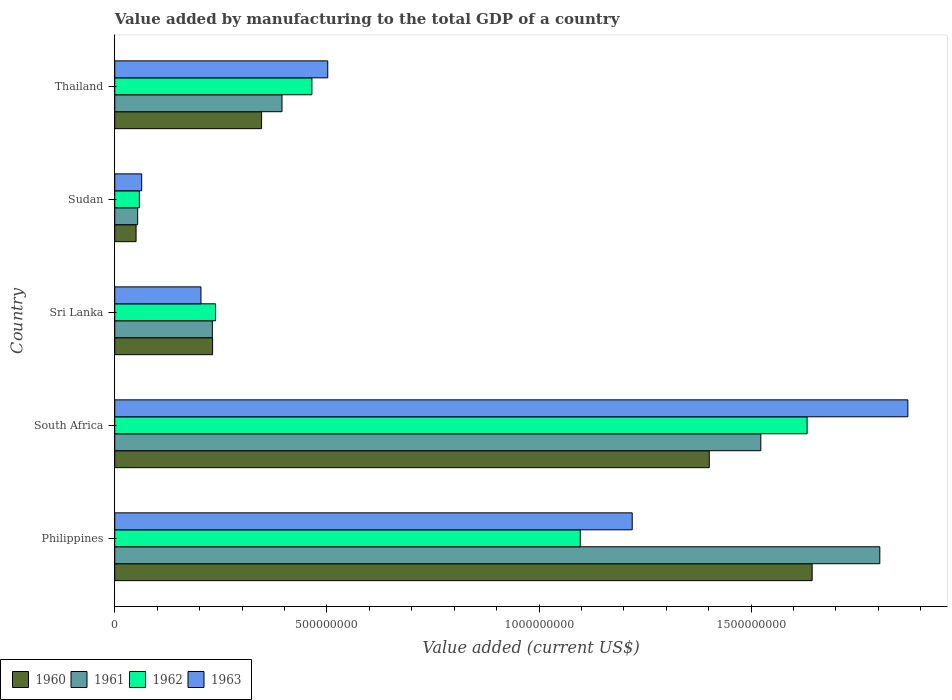How many different coloured bars are there?
Your answer should be very brief. 4. Are the number of bars per tick equal to the number of legend labels?
Keep it short and to the point. Yes. How many bars are there on the 2nd tick from the top?
Provide a succinct answer. 4. How many bars are there on the 5th tick from the bottom?
Provide a short and direct response. 4. What is the label of the 1st group of bars from the top?
Offer a terse response. Thailand. In how many cases, is the number of bars for a given country not equal to the number of legend labels?
Your answer should be very brief. 0. What is the value added by manufacturing to the total GDP in 1961 in Philippines?
Offer a very short reply. 1.80e+09. Across all countries, what is the maximum value added by manufacturing to the total GDP in 1960?
Your answer should be compact. 1.64e+09. Across all countries, what is the minimum value added by manufacturing to the total GDP in 1962?
Offer a terse response. 5.80e+07. In which country was the value added by manufacturing to the total GDP in 1962 maximum?
Your response must be concise. South Africa. In which country was the value added by manufacturing to the total GDP in 1963 minimum?
Make the answer very short. Sudan. What is the total value added by manufacturing to the total GDP in 1960 in the graph?
Make the answer very short. 3.67e+09. What is the difference between the value added by manufacturing to the total GDP in 1960 in Philippines and that in Thailand?
Your answer should be very brief. 1.30e+09. What is the difference between the value added by manufacturing to the total GDP in 1960 in Sudan and the value added by manufacturing to the total GDP in 1961 in Thailand?
Your answer should be very brief. -3.44e+08. What is the average value added by manufacturing to the total GDP in 1963 per country?
Your response must be concise. 7.72e+08. What is the difference between the value added by manufacturing to the total GDP in 1961 and value added by manufacturing to the total GDP in 1960 in Sri Lanka?
Keep it short and to the point. -6.30e+05. In how many countries, is the value added by manufacturing to the total GDP in 1963 greater than 1400000000 US$?
Give a very brief answer. 1. What is the ratio of the value added by manufacturing to the total GDP in 1961 in Sri Lanka to that in Sudan?
Offer a very short reply. 4.26. Is the value added by manufacturing to the total GDP in 1963 in South Africa less than that in Sri Lanka?
Your answer should be compact. No. Is the difference between the value added by manufacturing to the total GDP in 1961 in Philippines and Sudan greater than the difference between the value added by manufacturing to the total GDP in 1960 in Philippines and Sudan?
Your response must be concise. Yes. What is the difference between the highest and the second highest value added by manufacturing to the total GDP in 1963?
Offer a terse response. 6.50e+08. What is the difference between the highest and the lowest value added by manufacturing to the total GDP in 1960?
Your answer should be compact. 1.59e+09. In how many countries, is the value added by manufacturing to the total GDP in 1960 greater than the average value added by manufacturing to the total GDP in 1960 taken over all countries?
Keep it short and to the point. 2. Is the sum of the value added by manufacturing to the total GDP in 1960 in Sri Lanka and Thailand greater than the maximum value added by manufacturing to the total GDP in 1963 across all countries?
Make the answer very short. No. How many bars are there?
Make the answer very short. 20. Are all the bars in the graph horizontal?
Your answer should be very brief. Yes. How many countries are there in the graph?
Make the answer very short. 5. What is the difference between two consecutive major ticks on the X-axis?
Your answer should be compact. 5.00e+08. Does the graph contain any zero values?
Keep it short and to the point. No. Does the graph contain grids?
Offer a very short reply. No. How are the legend labels stacked?
Ensure brevity in your answer.  Horizontal. What is the title of the graph?
Your response must be concise. Value added by manufacturing to the total GDP of a country. What is the label or title of the X-axis?
Keep it short and to the point. Value added (current US$). What is the Value added (current US$) in 1960 in Philippines?
Give a very brief answer. 1.64e+09. What is the Value added (current US$) in 1961 in Philippines?
Your response must be concise. 1.80e+09. What is the Value added (current US$) in 1962 in Philippines?
Provide a short and direct response. 1.10e+09. What is the Value added (current US$) in 1963 in Philippines?
Your answer should be compact. 1.22e+09. What is the Value added (current US$) of 1960 in South Africa?
Make the answer very short. 1.40e+09. What is the Value added (current US$) in 1961 in South Africa?
Make the answer very short. 1.52e+09. What is the Value added (current US$) in 1962 in South Africa?
Your response must be concise. 1.63e+09. What is the Value added (current US$) in 1963 in South Africa?
Give a very brief answer. 1.87e+09. What is the Value added (current US$) in 1960 in Sri Lanka?
Provide a succinct answer. 2.31e+08. What is the Value added (current US$) in 1961 in Sri Lanka?
Your answer should be compact. 2.30e+08. What is the Value added (current US$) in 1962 in Sri Lanka?
Provide a succinct answer. 2.38e+08. What is the Value added (current US$) of 1963 in Sri Lanka?
Give a very brief answer. 2.03e+08. What is the Value added (current US$) in 1960 in Sudan?
Offer a terse response. 5.03e+07. What is the Value added (current US$) in 1961 in Sudan?
Offer a very short reply. 5.40e+07. What is the Value added (current US$) in 1962 in Sudan?
Give a very brief answer. 5.80e+07. What is the Value added (current US$) in 1963 in Sudan?
Keep it short and to the point. 6.35e+07. What is the Value added (current US$) in 1960 in Thailand?
Provide a succinct answer. 3.46e+08. What is the Value added (current US$) in 1961 in Thailand?
Provide a succinct answer. 3.94e+08. What is the Value added (current US$) in 1962 in Thailand?
Give a very brief answer. 4.65e+08. What is the Value added (current US$) in 1963 in Thailand?
Your answer should be compact. 5.02e+08. Across all countries, what is the maximum Value added (current US$) in 1960?
Your response must be concise. 1.64e+09. Across all countries, what is the maximum Value added (current US$) of 1961?
Keep it short and to the point. 1.80e+09. Across all countries, what is the maximum Value added (current US$) in 1962?
Your answer should be very brief. 1.63e+09. Across all countries, what is the maximum Value added (current US$) of 1963?
Your answer should be compact. 1.87e+09. Across all countries, what is the minimum Value added (current US$) in 1960?
Provide a succinct answer. 5.03e+07. Across all countries, what is the minimum Value added (current US$) of 1961?
Your answer should be very brief. 5.40e+07. Across all countries, what is the minimum Value added (current US$) in 1962?
Your response must be concise. 5.80e+07. Across all countries, what is the minimum Value added (current US$) of 1963?
Provide a short and direct response. 6.35e+07. What is the total Value added (current US$) in 1960 in the graph?
Provide a short and direct response. 3.67e+09. What is the total Value added (current US$) of 1961 in the graph?
Offer a terse response. 4.00e+09. What is the total Value added (current US$) of 1962 in the graph?
Offer a very short reply. 3.49e+09. What is the total Value added (current US$) in 1963 in the graph?
Make the answer very short. 3.86e+09. What is the difference between the Value added (current US$) of 1960 in Philippines and that in South Africa?
Your answer should be very brief. 2.43e+08. What is the difference between the Value added (current US$) in 1961 in Philippines and that in South Africa?
Your answer should be very brief. 2.80e+08. What is the difference between the Value added (current US$) of 1962 in Philippines and that in South Africa?
Your answer should be compact. -5.35e+08. What is the difference between the Value added (current US$) in 1963 in Philippines and that in South Africa?
Provide a succinct answer. -6.50e+08. What is the difference between the Value added (current US$) in 1960 in Philippines and that in Sri Lanka?
Provide a succinct answer. 1.41e+09. What is the difference between the Value added (current US$) in 1961 in Philippines and that in Sri Lanka?
Provide a succinct answer. 1.57e+09. What is the difference between the Value added (current US$) of 1962 in Philippines and that in Sri Lanka?
Offer a very short reply. 8.60e+08. What is the difference between the Value added (current US$) in 1963 in Philippines and that in Sri Lanka?
Offer a terse response. 1.02e+09. What is the difference between the Value added (current US$) in 1960 in Philippines and that in Sudan?
Your answer should be very brief. 1.59e+09. What is the difference between the Value added (current US$) in 1961 in Philippines and that in Sudan?
Offer a terse response. 1.75e+09. What is the difference between the Value added (current US$) of 1962 in Philippines and that in Sudan?
Your answer should be compact. 1.04e+09. What is the difference between the Value added (current US$) in 1963 in Philippines and that in Sudan?
Keep it short and to the point. 1.16e+09. What is the difference between the Value added (current US$) of 1960 in Philippines and that in Thailand?
Make the answer very short. 1.30e+09. What is the difference between the Value added (current US$) of 1961 in Philippines and that in Thailand?
Offer a terse response. 1.41e+09. What is the difference between the Value added (current US$) in 1962 in Philippines and that in Thailand?
Offer a terse response. 6.33e+08. What is the difference between the Value added (current US$) of 1963 in Philippines and that in Thailand?
Provide a succinct answer. 7.18e+08. What is the difference between the Value added (current US$) in 1960 in South Africa and that in Sri Lanka?
Give a very brief answer. 1.17e+09. What is the difference between the Value added (current US$) of 1961 in South Africa and that in Sri Lanka?
Provide a succinct answer. 1.29e+09. What is the difference between the Value added (current US$) in 1962 in South Africa and that in Sri Lanka?
Give a very brief answer. 1.39e+09. What is the difference between the Value added (current US$) in 1963 in South Africa and that in Sri Lanka?
Provide a short and direct response. 1.67e+09. What is the difference between the Value added (current US$) in 1960 in South Africa and that in Sudan?
Keep it short and to the point. 1.35e+09. What is the difference between the Value added (current US$) in 1961 in South Africa and that in Sudan?
Provide a short and direct response. 1.47e+09. What is the difference between the Value added (current US$) of 1962 in South Africa and that in Sudan?
Provide a short and direct response. 1.57e+09. What is the difference between the Value added (current US$) in 1963 in South Africa and that in Sudan?
Your answer should be compact. 1.81e+09. What is the difference between the Value added (current US$) in 1960 in South Africa and that in Thailand?
Make the answer very short. 1.06e+09. What is the difference between the Value added (current US$) in 1961 in South Africa and that in Thailand?
Your answer should be compact. 1.13e+09. What is the difference between the Value added (current US$) of 1962 in South Africa and that in Thailand?
Provide a short and direct response. 1.17e+09. What is the difference between the Value added (current US$) of 1963 in South Africa and that in Thailand?
Give a very brief answer. 1.37e+09. What is the difference between the Value added (current US$) in 1960 in Sri Lanka and that in Sudan?
Make the answer very short. 1.80e+08. What is the difference between the Value added (current US$) of 1961 in Sri Lanka and that in Sudan?
Provide a succinct answer. 1.76e+08. What is the difference between the Value added (current US$) in 1962 in Sri Lanka and that in Sudan?
Offer a very short reply. 1.80e+08. What is the difference between the Value added (current US$) of 1963 in Sri Lanka and that in Sudan?
Your answer should be very brief. 1.40e+08. What is the difference between the Value added (current US$) of 1960 in Sri Lanka and that in Thailand?
Keep it short and to the point. -1.15e+08. What is the difference between the Value added (current US$) of 1961 in Sri Lanka and that in Thailand?
Offer a terse response. -1.64e+08. What is the difference between the Value added (current US$) in 1962 in Sri Lanka and that in Thailand?
Provide a short and direct response. -2.27e+08. What is the difference between the Value added (current US$) of 1963 in Sri Lanka and that in Thailand?
Your response must be concise. -2.99e+08. What is the difference between the Value added (current US$) in 1960 in Sudan and that in Thailand?
Ensure brevity in your answer.  -2.96e+08. What is the difference between the Value added (current US$) of 1961 in Sudan and that in Thailand?
Provide a short and direct response. -3.40e+08. What is the difference between the Value added (current US$) in 1962 in Sudan and that in Thailand?
Provide a short and direct response. -4.07e+08. What is the difference between the Value added (current US$) in 1963 in Sudan and that in Thailand?
Your answer should be very brief. -4.39e+08. What is the difference between the Value added (current US$) of 1960 in Philippines and the Value added (current US$) of 1961 in South Africa?
Offer a very short reply. 1.21e+08. What is the difference between the Value added (current US$) of 1960 in Philippines and the Value added (current US$) of 1962 in South Africa?
Your answer should be compact. 1.19e+07. What is the difference between the Value added (current US$) of 1960 in Philippines and the Value added (current US$) of 1963 in South Africa?
Your response must be concise. -2.26e+08. What is the difference between the Value added (current US$) in 1961 in Philippines and the Value added (current US$) in 1962 in South Africa?
Provide a short and direct response. 1.71e+08. What is the difference between the Value added (current US$) of 1961 in Philippines and the Value added (current US$) of 1963 in South Africa?
Give a very brief answer. -6.61e+07. What is the difference between the Value added (current US$) in 1962 in Philippines and the Value added (current US$) in 1963 in South Africa?
Ensure brevity in your answer.  -7.72e+08. What is the difference between the Value added (current US$) of 1960 in Philippines and the Value added (current US$) of 1961 in Sri Lanka?
Ensure brevity in your answer.  1.41e+09. What is the difference between the Value added (current US$) in 1960 in Philippines and the Value added (current US$) in 1962 in Sri Lanka?
Your answer should be very brief. 1.41e+09. What is the difference between the Value added (current US$) in 1960 in Philippines and the Value added (current US$) in 1963 in Sri Lanka?
Offer a terse response. 1.44e+09. What is the difference between the Value added (current US$) of 1961 in Philippines and the Value added (current US$) of 1962 in Sri Lanka?
Make the answer very short. 1.57e+09. What is the difference between the Value added (current US$) in 1961 in Philippines and the Value added (current US$) in 1963 in Sri Lanka?
Give a very brief answer. 1.60e+09. What is the difference between the Value added (current US$) in 1962 in Philippines and the Value added (current US$) in 1963 in Sri Lanka?
Your answer should be very brief. 8.94e+08. What is the difference between the Value added (current US$) in 1960 in Philippines and the Value added (current US$) in 1961 in Sudan?
Make the answer very short. 1.59e+09. What is the difference between the Value added (current US$) in 1960 in Philippines and the Value added (current US$) in 1962 in Sudan?
Offer a very short reply. 1.59e+09. What is the difference between the Value added (current US$) of 1960 in Philippines and the Value added (current US$) of 1963 in Sudan?
Keep it short and to the point. 1.58e+09. What is the difference between the Value added (current US$) in 1961 in Philippines and the Value added (current US$) in 1962 in Sudan?
Make the answer very short. 1.75e+09. What is the difference between the Value added (current US$) in 1961 in Philippines and the Value added (current US$) in 1963 in Sudan?
Make the answer very short. 1.74e+09. What is the difference between the Value added (current US$) of 1962 in Philippines and the Value added (current US$) of 1963 in Sudan?
Provide a short and direct response. 1.03e+09. What is the difference between the Value added (current US$) of 1960 in Philippines and the Value added (current US$) of 1961 in Thailand?
Offer a very short reply. 1.25e+09. What is the difference between the Value added (current US$) in 1960 in Philippines and the Value added (current US$) in 1962 in Thailand?
Offer a very short reply. 1.18e+09. What is the difference between the Value added (current US$) in 1960 in Philippines and the Value added (current US$) in 1963 in Thailand?
Your response must be concise. 1.14e+09. What is the difference between the Value added (current US$) of 1961 in Philippines and the Value added (current US$) of 1962 in Thailand?
Give a very brief answer. 1.34e+09. What is the difference between the Value added (current US$) in 1961 in Philippines and the Value added (current US$) in 1963 in Thailand?
Ensure brevity in your answer.  1.30e+09. What is the difference between the Value added (current US$) of 1962 in Philippines and the Value added (current US$) of 1963 in Thailand?
Make the answer very short. 5.95e+08. What is the difference between the Value added (current US$) of 1960 in South Africa and the Value added (current US$) of 1961 in Sri Lanka?
Give a very brief answer. 1.17e+09. What is the difference between the Value added (current US$) in 1960 in South Africa and the Value added (current US$) in 1962 in Sri Lanka?
Give a very brief answer. 1.16e+09. What is the difference between the Value added (current US$) in 1960 in South Africa and the Value added (current US$) in 1963 in Sri Lanka?
Offer a very short reply. 1.20e+09. What is the difference between the Value added (current US$) in 1961 in South Africa and the Value added (current US$) in 1962 in Sri Lanka?
Offer a terse response. 1.29e+09. What is the difference between the Value added (current US$) of 1961 in South Africa and the Value added (current US$) of 1963 in Sri Lanka?
Give a very brief answer. 1.32e+09. What is the difference between the Value added (current US$) of 1962 in South Africa and the Value added (current US$) of 1963 in Sri Lanka?
Give a very brief answer. 1.43e+09. What is the difference between the Value added (current US$) of 1960 in South Africa and the Value added (current US$) of 1961 in Sudan?
Make the answer very short. 1.35e+09. What is the difference between the Value added (current US$) of 1960 in South Africa and the Value added (current US$) of 1962 in Sudan?
Your response must be concise. 1.34e+09. What is the difference between the Value added (current US$) of 1960 in South Africa and the Value added (current US$) of 1963 in Sudan?
Give a very brief answer. 1.34e+09. What is the difference between the Value added (current US$) of 1961 in South Africa and the Value added (current US$) of 1962 in Sudan?
Your answer should be very brief. 1.46e+09. What is the difference between the Value added (current US$) in 1961 in South Africa and the Value added (current US$) in 1963 in Sudan?
Provide a short and direct response. 1.46e+09. What is the difference between the Value added (current US$) in 1962 in South Africa and the Value added (current US$) in 1963 in Sudan?
Offer a terse response. 1.57e+09. What is the difference between the Value added (current US$) in 1960 in South Africa and the Value added (current US$) in 1961 in Thailand?
Your response must be concise. 1.01e+09. What is the difference between the Value added (current US$) in 1960 in South Africa and the Value added (current US$) in 1962 in Thailand?
Provide a succinct answer. 9.37e+08. What is the difference between the Value added (current US$) in 1960 in South Africa and the Value added (current US$) in 1963 in Thailand?
Make the answer very short. 8.99e+08. What is the difference between the Value added (current US$) of 1961 in South Africa and the Value added (current US$) of 1962 in Thailand?
Ensure brevity in your answer.  1.06e+09. What is the difference between the Value added (current US$) of 1961 in South Africa and the Value added (current US$) of 1963 in Thailand?
Your answer should be very brief. 1.02e+09. What is the difference between the Value added (current US$) in 1962 in South Africa and the Value added (current US$) in 1963 in Thailand?
Offer a very short reply. 1.13e+09. What is the difference between the Value added (current US$) in 1960 in Sri Lanka and the Value added (current US$) in 1961 in Sudan?
Make the answer very short. 1.77e+08. What is the difference between the Value added (current US$) of 1960 in Sri Lanka and the Value added (current US$) of 1962 in Sudan?
Give a very brief answer. 1.73e+08. What is the difference between the Value added (current US$) of 1960 in Sri Lanka and the Value added (current US$) of 1963 in Sudan?
Give a very brief answer. 1.67e+08. What is the difference between the Value added (current US$) of 1961 in Sri Lanka and the Value added (current US$) of 1962 in Sudan?
Ensure brevity in your answer.  1.72e+08. What is the difference between the Value added (current US$) of 1961 in Sri Lanka and the Value added (current US$) of 1963 in Sudan?
Provide a succinct answer. 1.67e+08. What is the difference between the Value added (current US$) of 1962 in Sri Lanka and the Value added (current US$) of 1963 in Sudan?
Your answer should be very brief. 1.74e+08. What is the difference between the Value added (current US$) of 1960 in Sri Lanka and the Value added (current US$) of 1961 in Thailand?
Your answer should be very brief. -1.64e+08. What is the difference between the Value added (current US$) of 1960 in Sri Lanka and the Value added (current US$) of 1962 in Thailand?
Keep it short and to the point. -2.34e+08. What is the difference between the Value added (current US$) of 1960 in Sri Lanka and the Value added (current US$) of 1963 in Thailand?
Your answer should be compact. -2.71e+08. What is the difference between the Value added (current US$) of 1961 in Sri Lanka and the Value added (current US$) of 1962 in Thailand?
Make the answer very short. -2.35e+08. What is the difference between the Value added (current US$) in 1961 in Sri Lanka and the Value added (current US$) in 1963 in Thailand?
Provide a short and direct response. -2.72e+08. What is the difference between the Value added (current US$) of 1962 in Sri Lanka and the Value added (current US$) of 1963 in Thailand?
Give a very brief answer. -2.64e+08. What is the difference between the Value added (current US$) of 1960 in Sudan and the Value added (current US$) of 1961 in Thailand?
Give a very brief answer. -3.44e+08. What is the difference between the Value added (current US$) in 1960 in Sudan and the Value added (current US$) in 1962 in Thailand?
Ensure brevity in your answer.  -4.14e+08. What is the difference between the Value added (current US$) of 1960 in Sudan and the Value added (current US$) of 1963 in Thailand?
Your answer should be very brief. -4.52e+08. What is the difference between the Value added (current US$) of 1961 in Sudan and the Value added (current US$) of 1962 in Thailand?
Your answer should be very brief. -4.11e+08. What is the difference between the Value added (current US$) of 1961 in Sudan and the Value added (current US$) of 1963 in Thailand?
Provide a succinct answer. -4.48e+08. What is the difference between the Value added (current US$) of 1962 in Sudan and the Value added (current US$) of 1963 in Thailand?
Your answer should be very brief. -4.44e+08. What is the average Value added (current US$) of 1960 per country?
Your response must be concise. 7.34e+08. What is the average Value added (current US$) of 1961 per country?
Give a very brief answer. 8.01e+08. What is the average Value added (current US$) of 1962 per country?
Your answer should be very brief. 6.98e+08. What is the average Value added (current US$) in 1963 per country?
Offer a very short reply. 7.72e+08. What is the difference between the Value added (current US$) in 1960 and Value added (current US$) in 1961 in Philippines?
Your answer should be very brief. -1.59e+08. What is the difference between the Value added (current US$) of 1960 and Value added (current US$) of 1962 in Philippines?
Ensure brevity in your answer.  5.47e+08. What is the difference between the Value added (current US$) in 1960 and Value added (current US$) in 1963 in Philippines?
Your answer should be compact. 4.24e+08. What is the difference between the Value added (current US$) in 1961 and Value added (current US$) in 1962 in Philippines?
Keep it short and to the point. 7.06e+08. What is the difference between the Value added (current US$) in 1961 and Value added (current US$) in 1963 in Philippines?
Offer a terse response. 5.84e+08. What is the difference between the Value added (current US$) of 1962 and Value added (current US$) of 1963 in Philippines?
Your answer should be very brief. -1.22e+08. What is the difference between the Value added (current US$) in 1960 and Value added (current US$) in 1961 in South Africa?
Your response must be concise. -1.21e+08. What is the difference between the Value added (current US$) of 1960 and Value added (current US$) of 1962 in South Africa?
Your answer should be very brief. -2.31e+08. What is the difference between the Value added (current US$) of 1960 and Value added (current US$) of 1963 in South Africa?
Your answer should be very brief. -4.68e+08. What is the difference between the Value added (current US$) of 1961 and Value added (current US$) of 1962 in South Africa?
Your response must be concise. -1.09e+08. What is the difference between the Value added (current US$) in 1961 and Value added (current US$) in 1963 in South Africa?
Offer a terse response. -3.47e+08. What is the difference between the Value added (current US$) of 1962 and Value added (current US$) of 1963 in South Africa?
Offer a terse response. -2.37e+08. What is the difference between the Value added (current US$) in 1960 and Value added (current US$) in 1961 in Sri Lanka?
Provide a short and direct response. 6.30e+05. What is the difference between the Value added (current US$) in 1960 and Value added (current US$) in 1962 in Sri Lanka?
Make the answer very short. -6.98e+06. What is the difference between the Value added (current US$) in 1960 and Value added (current US$) in 1963 in Sri Lanka?
Your answer should be compact. 2.75e+07. What is the difference between the Value added (current US$) of 1961 and Value added (current US$) of 1962 in Sri Lanka?
Your answer should be very brief. -7.61e+06. What is the difference between the Value added (current US$) in 1961 and Value added (current US$) in 1963 in Sri Lanka?
Your response must be concise. 2.68e+07. What is the difference between the Value added (current US$) in 1962 and Value added (current US$) in 1963 in Sri Lanka?
Offer a terse response. 3.45e+07. What is the difference between the Value added (current US$) of 1960 and Value added (current US$) of 1961 in Sudan?
Your response must be concise. -3.73e+06. What is the difference between the Value added (current US$) of 1960 and Value added (current US$) of 1962 in Sudan?
Provide a short and direct response. -7.75e+06. What is the difference between the Value added (current US$) in 1960 and Value added (current US$) in 1963 in Sudan?
Your answer should be compact. -1.32e+07. What is the difference between the Value added (current US$) in 1961 and Value added (current US$) in 1962 in Sudan?
Make the answer very short. -4.02e+06. What is the difference between the Value added (current US$) of 1961 and Value added (current US$) of 1963 in Sudan?
Make the answer very short. -9.48e+06. What is the difference between the Value added (current US$) of 1962 and Value added (current US$) of 1963 in Sudan?
Make the answer very short. -5.46e+06. What is the difference between the Value added (current US$) of 1960 and Value added (current US$) of 1961 in Thailand?
Offer a very short reply. -4.81e+07. What is the difference between the Value added (current US$) in 1960 and Value added (current US$) in 1962 in Thailand?
Your answer should be very brief. -1.19e+08. What is the difference between the Value added (current US$) of 1960 and Value added (current US$) of 1963 in Thailand?
Your response must be concise. -1.56e+08. What is the difference between the Value added (current US$) in 1961 and Value added (current US$) in 1962 in Thailand?
Your response must be concise. -7.05e+07. What is the difference between the Value added (current US$) in 1961 and Value added (current US$) in 1963 in Thailand?
Provide a succinct answer. -1.08e+08. What is the difference between the Value added (current US$) in 1962 and Value added (current US$) in 1963 in Thailand?
Offer a terse response. -3.73e+07. What is the ratio of the Value added (current US$) of 1960 in Philippines to that in South Africa?
Offer a terse response. 1.17. What is the ratio of the Value added (current US$) of 1961 in Philippines to that in South Africa?
Your answer should be very brief. 1.18. What is the ratio of the Value added (current US$) of 1962 in Philippines to that in South Africa?
Provide a short and direct response. 0.67. What is the ratio of the Value added (current US$) of 1963 in Philippines to that in South Africa?
Give a very brief answer. 0.65. What is the ratio of the Value added (current US$) in 1960 in Philippines to that in Sri Lanka?
Your response must be concise. 7.13. What is the ratio of the Value added (current US$) of 1961 in Philippines to that in Sri Lanka?
Your answer should be compact. 7.84. What is the ratio of the Value added (current US$) in 1962 in Philippines to that in Sri Lanka?
Keep it short and to the point. 4.62. What is the ratio of the Value added (current US$) in 1963 in Philippines to that in Sri Lanka?
Provide a short and direct response. 6. What is the ratio of the Value added (current US$) of 1960 in Philippines to that in Sudan?
Provide a succinct answer. 32.71. What is the ratio of the Value added (current US$) in 1961 in Philippines to that in Sudan?
Make the answer very short. 33.4. What is the ratio of the Value added (current US$) in 1962 in Philippines to that in Sudan?
Ensure brevity in your answer.  18.91. What is the ratio of the Value added (current US$) of 1963 in Philippines to that in Sudan?
Ensure brevity in your answer.  19.22. What is the ratio of the Value added (current US$) in 1960 in Philippines to that in Thailand?
Your response must be concise. 4.75. What is the ratio of the Value added (current US$) of 1961 in Philippines to that in Thailand?
Your answer should be compact. 4.57. What is the ratio of the Value added (current US$) of 1962 in Philippines to that in Thailand?
Your answer should be very brief. 2.36. What is the ratio of the Value added (current US$) of 1963 in Philippines to that in Thailand?
Offer a terse response. 2.43. What is the ratio of the Value added (current US$) of 1960 in South Africa to that in Sri Lanka?
Provide a short and direct response. 6.08. What is the ratio of the Value added (current US$) in 1961 in South Africa to that in Sri Lanka?
Ensure brevity in your answer.  6.62. What is the ratio of the Value added (current US$) in 1962 in South Africa to that in Sri Lanka?
Keep it short and to the point. 6.87. What is the ratio of the Value added (current US$) of 1963 in South Africa to that in Sri Lanka?
Make the answer very short. 9.2. What is the ratio of the Value added (current US$) of 1960 in South Africa to that in Sudan?
Give a very brief answer. 27.88. What is the ratio of the Value added (current US$) of 1961 in South Africa to that in Sudan?
Your response must be concise. 28.21. What is the ratio of the Value added (current US$) of 1962 in South Africa to that in Sudan?
Provide a succinct answer. 28.13. What is the ratio of the Value added (current US$) in 1963 in South Africa to that in Sudan?
Provide a short and direct response. 29.45. What is the ratio of the Value added (current US$) in 1960 in South Africa to that in Thailand?
Offer a very short reply. 4.05. What is the ratio of the Value added (current US$) of 1961 in South Africa to that in Thailand?
Make the answer very short. 3.86. What is the ratio of the Value added (current US$) of 1962 in South Africa to that in Thailand?
Give a very brief answer. 3.51. What is the ratio of the Value added (current US$) in 1963 in South Africa to that in Thailand?
Make the answer very short. 3.72. What is the ratio of the Value added (current US$) of 1960 in Sri Lanka to that in Sudan?
Keep it short and to the point. 4.59. What is the ratio of the Value added (current US$) in 1961 in Sri Lanka to that in Sudan?
Your response must be concise. 4.26. What is the ratio of the Value added (current US$) in 1962 in Sri Lanka to that in Sudan?
Your response must be concise. 4.1. What is the ratio of the Value added (current US$) of 1963 in Sri Lanka to that in Sudan?
Your answer should be compact. 3.2. What is the ratio of the Value added (current US$) of 1960 in Sri Lanka to that in Thailand?
Ensure brevity in your answer.  0.67. What is the ratio of the Value added (current US$) in 1961 in Sri Lanka to that in Thailand?
Your response must be concise. 0.58. What is the ratio of the Value added (current US$) in 1962 in Sri Lanka to that in Thailand?
Provide a short and direct response. 0.51. What is the ratio of the Value added (current US$) in 1963 in Sri Lanka to that in Thailand?
Make the answer very short. 0.4. What is the ratio of the Value added (current US$) of 1960 in Sudan to that in Thailand?
Make the answer very short. 0.15. What is the ratio of the Value added (current US$) of 1961 in Sudan to that in Thailand?
Provide a short and direct response. 0.14. What is the ratio of the Value added (current US$) of 1962 in Sudan to that in Thailand?
Your answer should be very brief. 0.12. What is the ratio of the Value added (current US$) of 1963 in Sudan to that in Thailand?
Your answer should be very brief. 0.13. What is the difference between the highest and the second highest Value added (current US$) in 1960?
Offer a terse response. 2.43e+08. What is the difference between the highest and the second highest Value added (current US$) of 1961?
Provide a short and direct response. 2.80e+08. What is the difference between the highest and the second highest Value added (current US$) in 1962?
Your response must be concise. 5.35e+08. What is the difference between the highest and the second highest Value added (current US$) of 1963?
Offer a terse response. 6.50e+08. What is the difference between the highest and the lowest Value added (current US$) in 1960?
Give a very brief answer. 1.59e+09. What is the difference between the highest and the lowest Value added (current US$) of 1961?
Make the answer very short. 1.75e+09. What is the difference between the highest and the lowest Value added (current US$) of 1962?
Ensure brevity in your answer.  1.57e+09. What is the difference between the highest and the lowest Value added (current US$) in 1963?
Offer a terse response. 1.81e+09. 